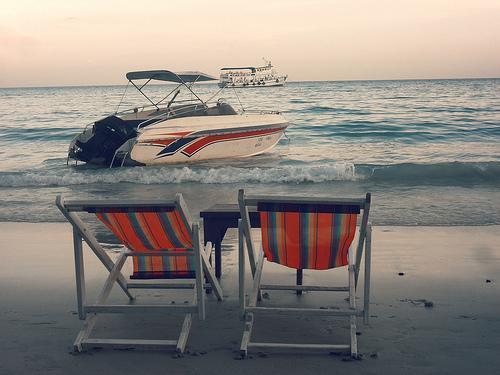How many chairs are there?
Give a very brief answer. 2. 